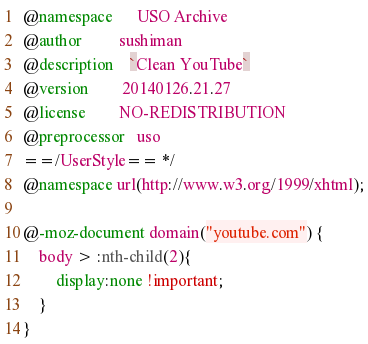Convert code to text. <code><loc_0><loc_0><loc_500><loc_500><_CSS_>@namespace      USO Archive
@author         sushiman
@description    `Clean YouTube`
@version        20140126.21.27
@license        NO-REDISTRIBUTION
@preprocessor   uso
==/UserStyle== */
@namespace url(http://www.w3.org/1999/xhtml);

@-moz-document domain("youtube.com") {
    body > :nth-child(2){
        display:none !important;
    }
}</code> 